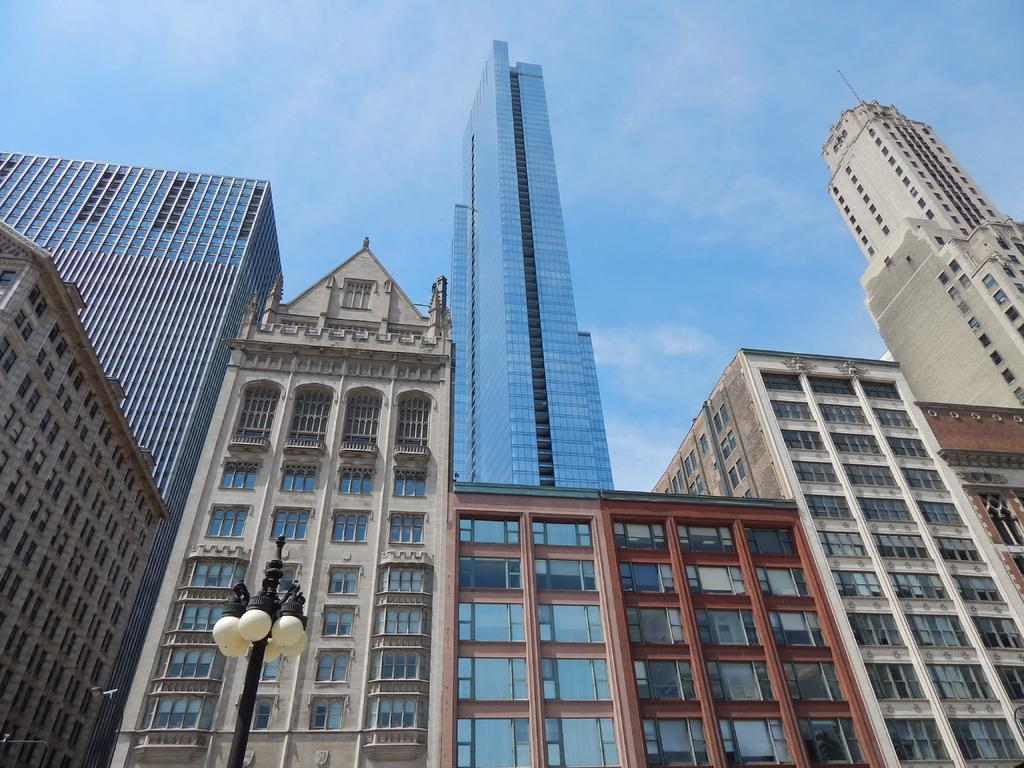What type of structures are visible in the image? There are many buildings with windows in the image. What is located at the bottom of the image? There is a pole with lights at the bottom of the image. What can be seen in the background of the image? The sky is visible in the background of the image. What type of music can be heard playing in the image? There is no music present in the image, as it only features buildings, a pole with lights, and the sky. 